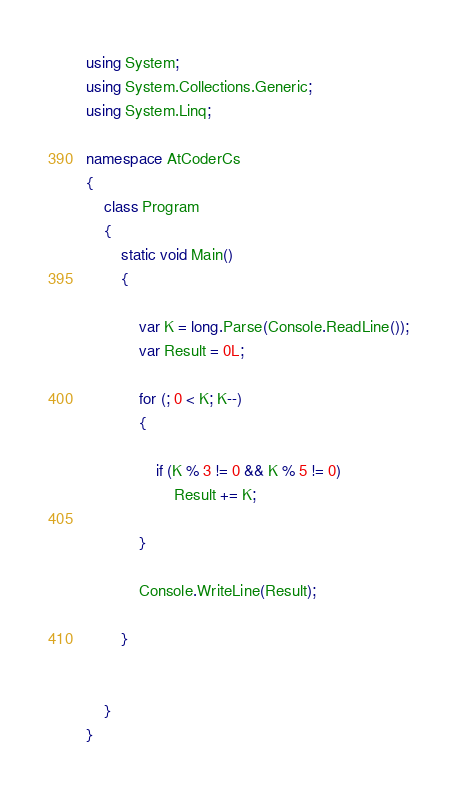Convert code to text. <code><loc_0><loc_0><loc_500><loc_500><_C#_>using System;
using System.Collections.Generic;
using System.Linq;

namespace AtCoderCs
{
    class Program
    {
        static void Main()
        {

            var K = long.Parse(Console.ReadLine());
            var Result = 0L;

            for (; 0 < K; K--)
            {

                if (K % 3 != 0 && K % 5 != 0) 
                    Result += K;

            }

            Console.WriteLine(Result);

        }


    }
}
</code> 